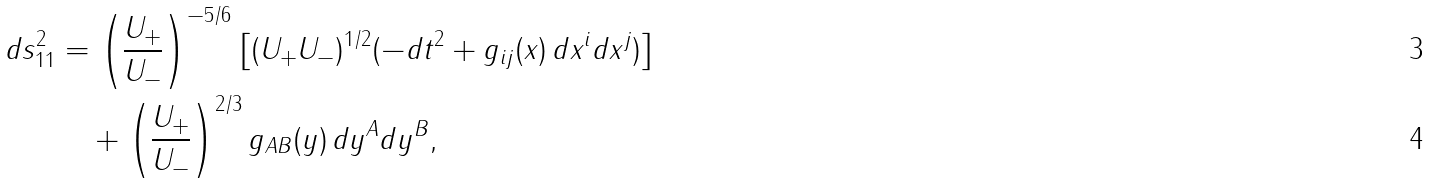Convert formula to latex. <formula><loc_0><loc_0><loc_500><loc_500>d s _ { 1 1 } ^ { 2 } & = \left ( \frac { U _ { + } } { U _ { - } } \right ) ^ { - 5 / 6 } \left [ ( U _ { + } U _ { - } ) ^ { 1 / 2 } ( - d t ^ { 2 } + g _ { i j } ( x ) \, d x ^ { i } d x ^ { j } ) \right ] \\ & \quad + \left ( \frac { U _ { + } } { U _ { - } } \right ) ^ { 2 / 3 } g _ { A B } ( y ) \, d y ^ { A } d y ^ { B } ,</formula> 